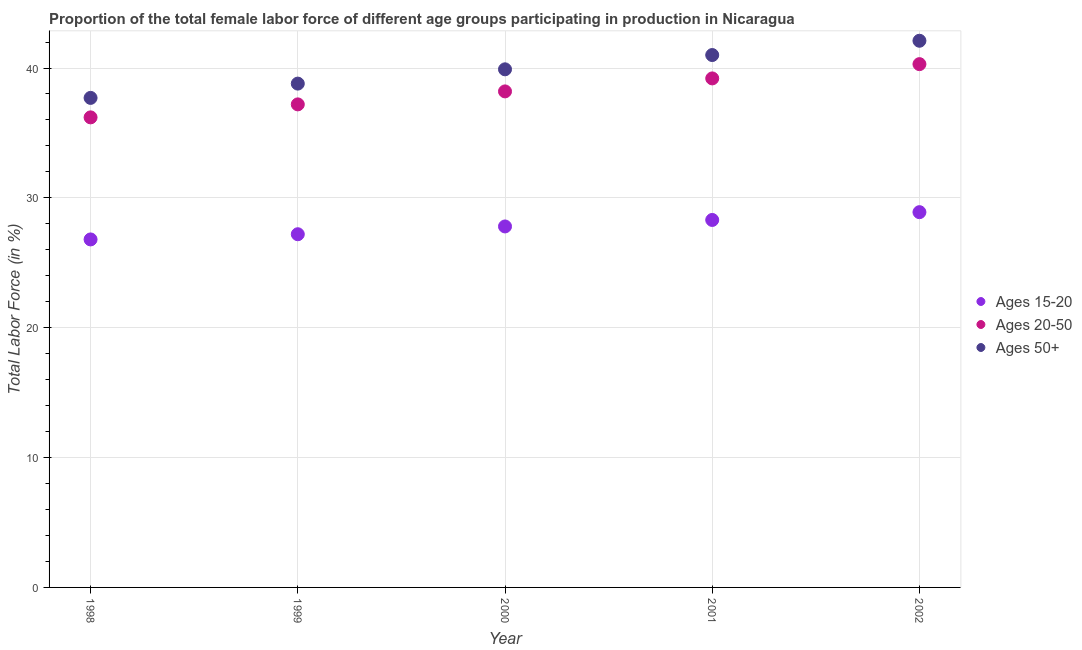Is the number of dotlines equal to the number of legend labels?
Give a very brief answer. Yes. What is the percentage of female labor force above age 50 in 2001?
Your response must be concise. 41. Across all years, what is the maximum percentage of female labor force within the age group 20-50?
Offer a terse response. 40.3. Across all years, what is the minimum percentage of female labor force above age 50?
Ensure brevity in your answer.  37.7. In which year was the percentage of female labor force within the age group 20-50 maximum?
Provide a short and direct response. 2002. What is the total percentage of female labor force within the age group 15-20 in the graph?
Your answer should be very brief. 139. What is the difference between the percentage of female labor force within the age group 20-50 in 1999 and that in 2001?
Ensure brevity in your answer.  -2. What is the difference between the percentage of female labor force within the age group 20-50 in 2001 and the percentage of female labor force above age 50 in 1999?
Give a very brief answer. 0.4. What is the average percentage of female labor force within the age group 15-20 per year?
Offer a terse response. 27.8. In the year 2002, what is the difference between the percentage of female labor force within the age group 15-20 and percentage of female labor force above age 50?
Give a very brief answer. -13.2. What is the ratio of the percentage of female labor force within the age group 20-50 in 1999 to that in 2002?
Provide a succinct answer. 0.92. Is the percentage of female labor force within the age group 15-20 in 1998 less than that in 2000?
Your answer should be very brief. Yes. What is the difference between the highest and the second highest percentage of female labor force above age 50?
Offer a terse response. 1.1. What is the difference between the highest and the lowest percentage of female labor force above age 50?
Your answer should be compact. 4.4. In how many years, is the percentage of female labor force above age 50 greater than the average percentage of female labor force above age 50 taken over all years?
Keep it short and to the point. 3. Is the sum of the percentage of female labor force above age 50 in 1998 and 1999 greater than the maximum percentage of female labor force within the age group 20-50 across all years?
Offer a very short reply. Yes. Is it the case that in every year, the sum of the percentage of female labor force within the age group 15-20 and percentage of female labor force within the age group 20-50 is greater than the percentage of female labor force above age 50?
Provide a succinct answer. Yes. Is the percentage of female labor force within the age group 20-50 strictly less than the percentage of female labor force within the age group 15-20 over the years?
Make the answer very short. No. What is the difference between two consecutive major ticks on the Y-axis?
Your answer should be very brief. 10. Are the values on the major ticks of Y-axis written in scientific E-notation?
Give a very brief answer. No. Does the graph contain any zero values?
Provide a short and direct response. No. Does the graph contain grids?
Provide a succinct answer. Yes. Where does the legend appear in the graph?
Give a very brief answer. Center right. What is the title of the graph?
Ensure brevity in your answer.  Proportion of the total female labor force of different age groups participating in production in Nicaragua. What is the label or title of the Y-axis?
Keep it short and to the point. Total Labor Force (in %). What is the Total Labor Force (in %) of Ages 15-20 in 1998?
Provide a succinct answer. 26.8. What is the Total Labor Force (in %) of Ages 20-50 in 1998?
Your response must be concise. 36.2. What is the Total Labor Force (in %) of Ages 50+ in 1998?
Make the answer very short. 37.7. What is the Total Labor Force (in %) in Ages 15-20 in 1999?
Your answer should be compact. 27.2. What is the Total Labor Force (in %) in Ages 20-50 in 1999?
Your answer should be compact. 37.2. What is the Total Labor Force (in %) of Ages 50+ in 1999?
Keep it short and to the point. 38.8. What is the Total Labor Force (in %) in Ages 15-20 in 2000?
Offer a very short reply. 27.8. What is the Total Labor Force (in %) of Ages 20-50 in 2000?
Give a very brief answer. 38.2. What is the Total Labor Force (in %) of Ages 50+ in 2000?
Give a very brief answer. 39.9. What is the Total Labor Force (in %) in Ages 15-20 in 2001?
Your response must be concise. 28.3. What is the Total Labor Force (in %) in Ages 20-50 in 2001?
Provide a succinct answer. 39.2. What is the Total Labor Force (in %) in Ages 50+ in 2001?
Make the answer very short. 41. What is the Total Labor Force (in %) of Ages 15-20 in 2002?
Ensure brevity in your answer.  28.9. What is the Total Labor Force (in %) in Ages 20-50 in 2002?
Offer a very short reply. 40.3. What is the Total Labor Force (in %) in Ages 50+ in 2002?
Provide a short and direct response. 42.1. Across all years, what is the maximum Total Labor Force (in %) of Ages 15-20?
Your answer should be very brief. 28.9. Across all years, what is the maximum Total Labor Force (in %) in Ages 20-50?
Keep it short and to the point. 40.3. Across all years, what is the maximum Total Labor Force (in %) of Ages 50+?
Provide a succinct answer. 42.1. Across all years, what is the minimum Total Labor Force (in %) of Ages 15-20?
Your answer should be compact. 26.8. Across all years, what is the minimum Total Labor Force (in %) in Ages 20-50?
Offer a very short reply. 36.2. Across all years, what is the minimum Total Labor Force (in %) of Ages 50+?
Your answer should be very brief. 37.7. What is the total Total Labor Force (in %) of Ages 15-20 in the graph?
Give a very brief answer. 139. What is the total Total Labor Force (in %) in Ages 20-50 in the graph?
Keep it short and to the point. 191.1. What is the total Total Labor Force (in %) of Ages 50+ in the graph?
Offer a terse response. 199.5. What is the difference between the Total Labor Force (in %) in Ages 20-50 in 1998 and that in 2000?
Give a very brief answer. -2. What is the difference between the Total Labor Force (in %) in Ages 50+ in 1998 and that in 2000?
Ensure brevity in your answer.  -2.2. What is the difference between the Total Labor Force (in %) in Ages 50+ in 1998 and that in 2001?
Provide a succinct answer. -3.3. What is the difference between the Total Labor Force (in %) in Ages 15-20 in 1998 and that in 2002?
Ensure brevity in your answer.  -2.1. What is the difference between the Total Labor Force (in %) of Ages 20-50 in 1998 and that in 2002?
Your answer should be compact. -4.1. What is the difference between the Total Labor Force (in %) of Ages 15-20 in 1999 and that in 2000?
Give a very brief answer. -0.6. What is the difference between the Total Labor Force (in %) in Ages 20-50 in 1999 and that in 2000?
Give a very brief answer. -1. What is the difference between the Total Labor Force (in %) in Ages 50+ in 1999 and that in 2000?
Provide a short and direct response. -1.1. What is the difference between the Total Labor Force (in %) in Ages 15-20 in 1999 and that in 2001?
Your answer should be very brief. -1.1. What is the difference between the Total Labor Force (in %) in Ages 50+ in 1999 and that in 2001?
Provide a succinct answer. -2.2. What is the difference between the Total Labor Force (in %) in Ages 20-50 in 1999 and that in 2002?
Keep it short and to the point. -3.1. What is the difference between the Total Labor Force (in %) of Ages 50+ in 1999 and that in 2002?
Your answer should be compact. -3.3. What is the difference between the Total Labor Force (in %) in Ages 50+ in 2000 and that in 2001?
Your answer should be compact. -1.1. What is the difference between the Total Labor Force (in %) of Ages 15-20 in 2000 and that in 2002?
Your answer should be compact. -1.1. What is the difference between the Total Labor Force (in %) in Ages 20-50 in 2000 and that in 2002?
Your answer should be compact. -2.1. What is the difference between the Total Labor Force (in %) of Ages 20-50 in 2001 and that in 2002?
Give a very brief answer. -1.1. What is the difference between the Total Labor Force (in %) of Ages 50+ in 2001 and that in 2002?
Provide a succinct answer. -1.1. What is the difference between the Total Labor Force (in %) in Ages 15-20 in 1998 and the Total Labor Force (in %) in Ages 50+ in 1999?
Provide a succinct answer. -12. What is the difference between the Total Labor Force (in %) of Ages 20-50 in 1998 and the Total Labor Force (in %) of Ages 50+ in 1999?
Ensure brevity in your answer.  -2.6. What is the difference between the Total Labor Force (in %) of Ages 15-20 in 1998 and the Total Labor Force (in %) of Ages 20-50 in 2000?
Provide a succinct answer. -11.4. What is the difference between the Total Labor Force (in %) in Ages 15-20 in 1998 and the Total Labor Force (in %) in Ages 50+ in 2001?
Your response must be concise. -14.2. What is the difference between the Total Labor Force (in %) of Ages 20-50 in 1998 and the Total Labor Force (in %) of Ages 50+ in 2001?
Provide a succinct answer. -4.8. What is the difference between the Total Labor Force (in %) of Ages 15-20 in 1998 and the Total Labor Force (in %) of Ages 50+ in 2002?
Your answer should be very brief. -15.3. What is the difference between the Total Labor Force (in %) of Ages 15-20 in 1999 and the Total Labor Force (in %) of Ages 50+ in 2000?
Keep it short and to the point. -12.7. What is the difference between the Total Labor Force (in %) of Ages 20-50 in 1999 and the Total Labor Force (in %) of Ages 50+ in 2000?
Offer a very short reply. -2.7. What is the difference between the Total Labor Force (in %) in Ages 15-20 in 1999 and the Total Labor Force (in %) in Ages 20-50 in 2001?
Make the answer very short. -12. What is the difference between the Total Labor Force (in %) in Ages 15-20 in 1999 and the Total Labor Force (in %) in Ages 50+ in 2001?
Provide a succinct answer. -13.8. What is the difference between the Total Labor Force (in %) in Ages 20-50 in 1999 and the Total Labor Force (in %) in Ages 50+ in 2001?
Offer a very short reply. -3.8. What is the difference between the Total Labor Force (in %) of Ages 15-20 in 1999 and the Total Labor Force (in %) of Ages 50+ in 2002?
Offer a terse response. -14.9. What is the difference between the Total Labor Force (in %) in Ages 20-50 in 1999 and the Total Labor Force (in %) in Ages 50+ in 2002?
Provide a short and direct response. -4.9. What is the difference between the Total Labor Force (in %) of Ages 15-20 in 2000 and the Total Labor Force (in %) of Ages 20-50 in 2001?
Offer a terse response. -11.4. What is the difference between the Total Labor Force (in %) in Ages 20-50 in 2000 and the Total Labor Force (in %) in Ages 50+ in 2001?
Provide a succinct answer. -2.8. What is the difference between the Total Labor Force (in %) in Ages 15-20 in 2000 and the Total Labor Force (in %) in Ages 20-50 in 2002?
Give a very brief answer. -12.5. What is the difference between the Total Labor Force (in %) of Ages 15-20 in 2000 and the Total Labor Force (in %) of Ages 50+ in 2002?
Provide a succinct answer. -14.3. What is the difference between the Total Labor Force (in %) of Ages 20-50 in 2000 and the Total Labor Force (in %) of Ages 50+ in 2002?
Offer a very short reply. -3.9. What is the average Total Labor Force (in %) in Ages 15-20 per year?
Your response must be concise. 27.8. What is the average Total Labor Force (in %) in Ages 20-50 per year?
Ensure brevity in your answer.  38.22. What is the average Total Labor Force (in %) of Ages 50+ per year?
Ensure brevity in your answer.  39.9. In the year 1998, what is the difference between the Total Labor Force (in %) in Ages 15-20 and Total Labor Force (in %) in Ages 20-50?
Provide a succinct answer. -9.4. In the year 1998, what is the difference between the Total Labor Force (in %) of Ages 20-50 and Total Labor Force (in %) of Ages 50+?
Your response must be concise. -1.5. In the year 2000, what is the difference between the Total Labor Force (in %) of Ages 15-20 and Total Labor Force (in %) of Ages 20-50?
Provide a short and direct response. -10.4. In the year 2000, what is the difference between the Total Labor Force (in %) in Ages 15-20 and Total Labor Force (in %) in Ages 50+?
Offer a very short reply. -12.1. In the year 2001, what is the difference between the Total Labor Force (in %) in Ages 15-20 and Total Labor Force (in %) in Ages 50+?
Offer a terse response. -12.7. In the year 2002, what is the difference between the Total Labor Force (in %) in Ages 15-20 and Total Labor Force (in %) in Ages 20-50?
Offer a terse response. -11.4. In the year 2002, what is the difference between the Total Labor Force (in %) in Ages 15-20 and Total Labor Force (in %) in Ages 50+?
Provide a succinct answer. -13.2. In the year 2002, what is the difference between the Total Labor Force (in %) of Ages 20-50 and Total Labor Force (in %) of Ages 50+?
Provide a short and direct response. -1.8. What is the ratio of the Total Labor Force (in %) of Ages 15-20 in 1998 to that in 1999?
Offer a terse response. 0.99. What is the ratio of the Total Labor Force (in %) of Ages 20-50 in 1998 to that in 1999?
Offer a terse response. 0.97. What is the ratio of the Total Labor Force (in %) in Ages 50+ in 1998 to that in 1999?
Ensure brevity in your answer.  0.97. What is the ratio of the Total Labor Force (in %) of Ages 20-50 in 1998 to that in 2000?
Provide a succinct answer. 0.95. What is the ratio of the Total Labor Force (in %) in Ages 50+ in 1998 to that in 2000?
Your response must be concise. 0.94. What is the ratio of the Total Labor Force (in %) of Ages 15-20 in 1998 to that in 2001?
Your answer should be compact. 0.95. What is the ratio of the Total Labor Force (in %) in Ages 20-50 in 1998 to that in 2001?
Offer a very short reply. 0.92. What is the ratio of the Total Labor Force (in %) of Ages 50+ in 1998 to that in 2001?
Ensure brevity in your answer.  0.92. What is the ratio of the Total Labor Force (in %) in Ages 15-20 in 1998 to that in 2002?
Provide a succinct answer. 0.93. What is the ratio of the Total Labor Force (in %) of Ages 20-50 in 1998 to that in 2002?
Give a very brief answer. 0.9. What is the ratio of the Total Labor Force (in %) of Ages 50+ in 1998 to that in 2002?
Keep it short and to the point. 0.9. What is the ratio of the Total Labor Force (in %) of Ages 15-20 in 1999 to that in 2000?
Offer a very short reply. 0.98. What is the ratio of the Total Labor Force (in %) of Ages 20-50 in 1999 to that in 2000?
Keep it short and to the point. 0.97. What is the ratio of the Total Labor Force (in %) of Ages 50+ in 1999 to that in 2000?
Offer a very short reply. 0.97. What is the ratio of the Total Labor Force (in %) in Ages 15-20 in 1999 to that in 2001?
Offer a very short reply. 0.96. What is the ratio of the Total Labor Force (in %) of Ages 20-50 in 1999 to that in 2001?
Your answer should be compact. 0.95. What is the ratio of the Total Labor Force (in %) of Ages 50+ in 1999 to that in 2001?
Give a very brief answer. 0.95. What is the ratio of the Total Labor Force (in %) in Ages 50+ in 1999 to that in 2002?
Make the answer very short. 0.92. What is the ratio of the Total Labor Force (in %) of Ages 15-20 in 2000 to that in 2001?
Offer a terse response. 0.98. What is the ratio of the Total Labor Force (in %) of Ages 20-50 in 2000 to that in 2001?
Offer a very short reply. 0.97. What is the ratio of the Total Labor Force (in %) of Ages 50+ in 2000 to that in 2001?
Keep it short and to the point. 0.97. What is the ratio of the Total Labor Force (in %) in Ages 15-20 in 2000 to that in 2002?
Give a very brief answer. 0.96. What is the ratio of the Total Labor Force (in %) in Ages 20-50 in 2000 to that in 2002?
Provide a succinct answer. 0.95. What is the ratio of the Total Labor Force (in %) in Ages 50+ in 2000 to that in 2002?
Ensure brevity in your answer.  0.95. What is the ratio of the Total Labor Force (in %) of Ages 15-20 in 2001 to that in 2002?
Your answer should be compact. 0.98. What is the ratio of the Total Labor Force (in %) in Ages 20-50 in 2001 to that in 2002?
Provide a succinct answer. 0.97. What is the ratio of the Total Labor Force (in %) of Ages 50+ in 2001 to that in 2002?
Your answer should be very brief. 0.97. What is the difference between the highest and the second highest Total Labor Force (in %) in Ages 15-20?
Your answer should be very brief. 0.6. What is the difference between the highest and the second highest Total Labor Force (in %) of Ages 50+?
Keep it short and to the point. 1.1. 